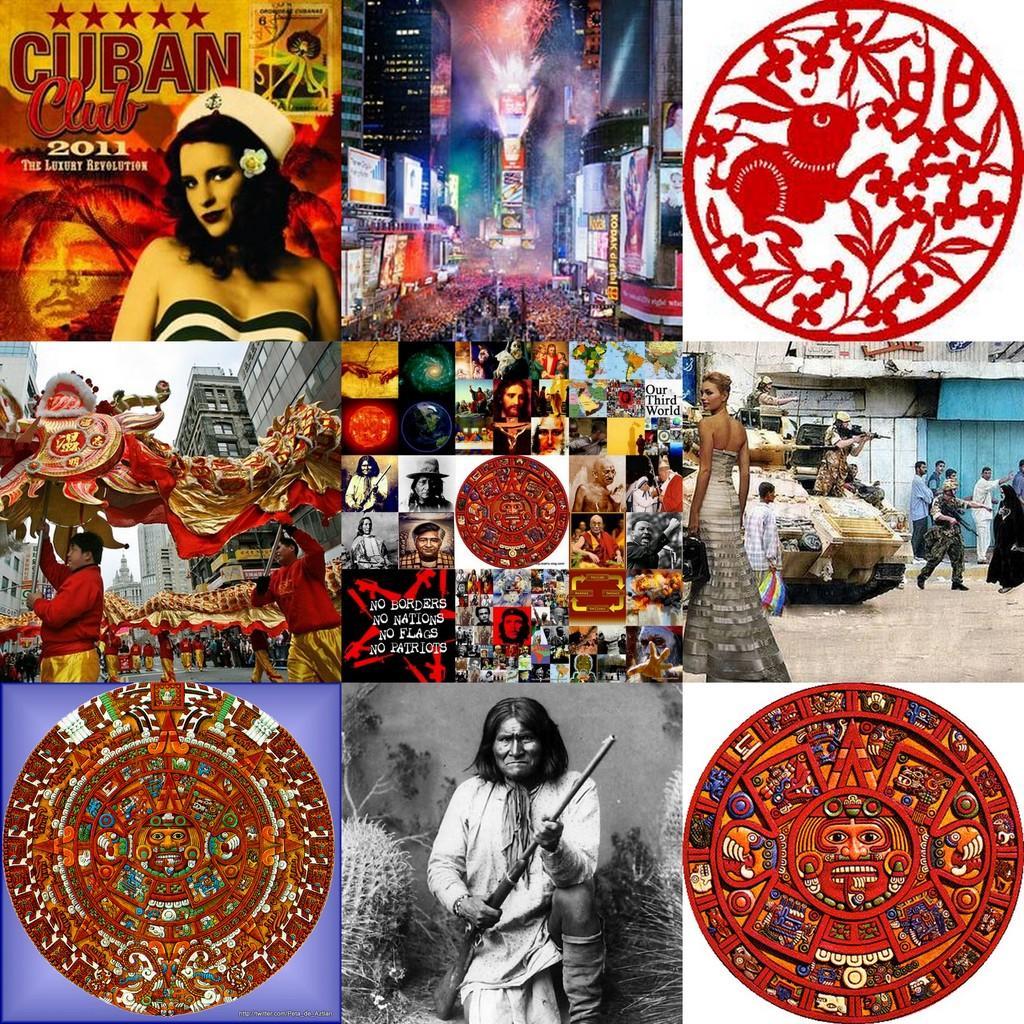Can you describe this image briefly? In this image we can see there are many photos in one image, at the bottom we can see a person holding a gun and at the top we can see a person, and there are some logos. 